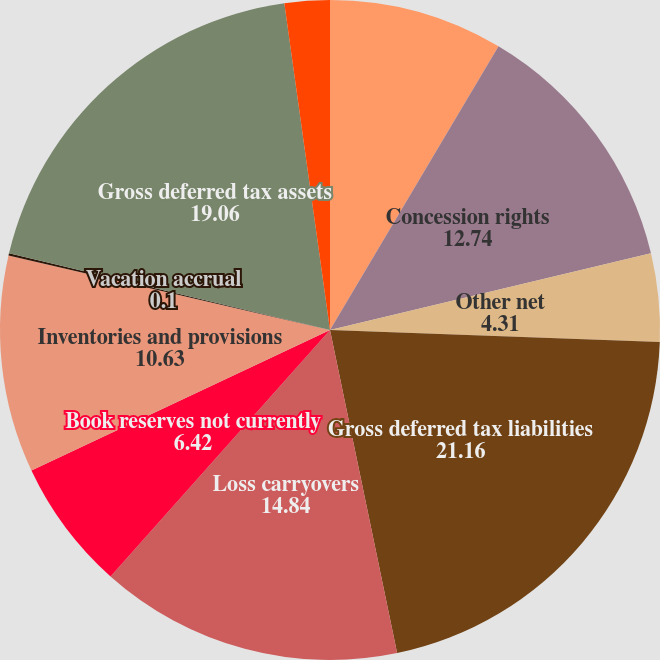<chart> <loc_0><loc_0><loc_500><loc_500><pie_chart><fcel>Investments<fcel>Concession rights<fcel>Other net<fcel>Gross deferred tax liabilities<fcel>Loss carryovers<fcel>Book reserves not currently<fcel>Inventories and provisions<fcel>Vacation accrual<fcel>Gross deferred tax assets<fcel>Valuation allowance on loss<nl><fcel>8.53%<fcel>12.74%<fcel>4.31%<fcel>21.16%<fcel>14.84%<fcel>6.42%<fcel>10.63%<fcel>0.1%<fcel>19.06%<fcel>2.21%<nl></chart> 